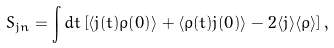<formula> <loc_0><loc_0><loc_500><loc_500>S _ { j n } = \int d t \left [ \langle j ( t ) \rho ( 0 ) \rangle + \langle \rho ( t ) j ( 0 ) \rangle - 2 \langle j \rangle \langle \rho \rangle \right ] ,</formula> 